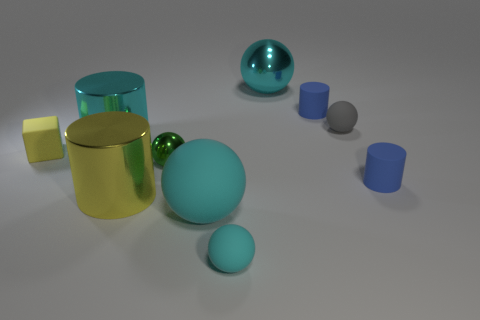There is a cyan rubber object that is the same size as the green ball; what is its shape?
Make the answer very short. Sphere. What material is the big ball that is behind the big cyan metal object in front of the big cyan ball that is behind the large yellow shiny object?
Your response must be concise. Metal. There is a big cylinder that is the same color as the large rubber sphere; what is its material?
Offer a very short reply. Metal. Are there any other things that are the same shape as the small yellow matte thing?
Your answer should be very brief. No. What number of objects are cyan rubber spheres that are right of the large cyan matte ball or small cylinders?
Your response must be concise. 3. There is a shiny cylinder that is on the left side of the large yellow metal thing; does it have the same color as the large matte object?
Provide a succinct answer. Yes. What is the shape of the big cyan metallic thing that is behind the large cyan thing that is to the left of the yellow cylinder?
Provide a succinct answer. Sphere. Are there fewer small rubber balls that are in front of the gray rubber sphere than small gray rubber spheres in front of the tiny cyan matte object?
Your answer should be very brief. No. The gray thing that is the same shape as the tiny green metal thing is what size?
Provide a succinct answer. Small. What number of objects are large metallic things that are behind the big yellow metal cylinder or small matte objects that are to the left of the big rubber sphere?
Offer a terse response. 3. 